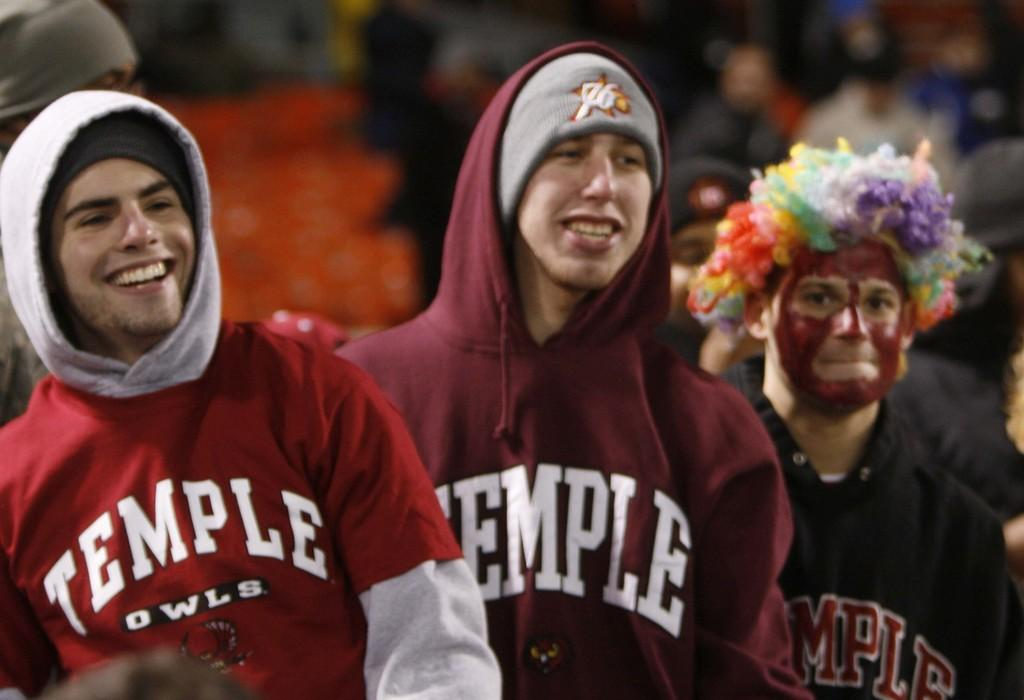Provide a one-sentence caption for the provided image. Three men are wearing clothing that says TEMPLE on them. 